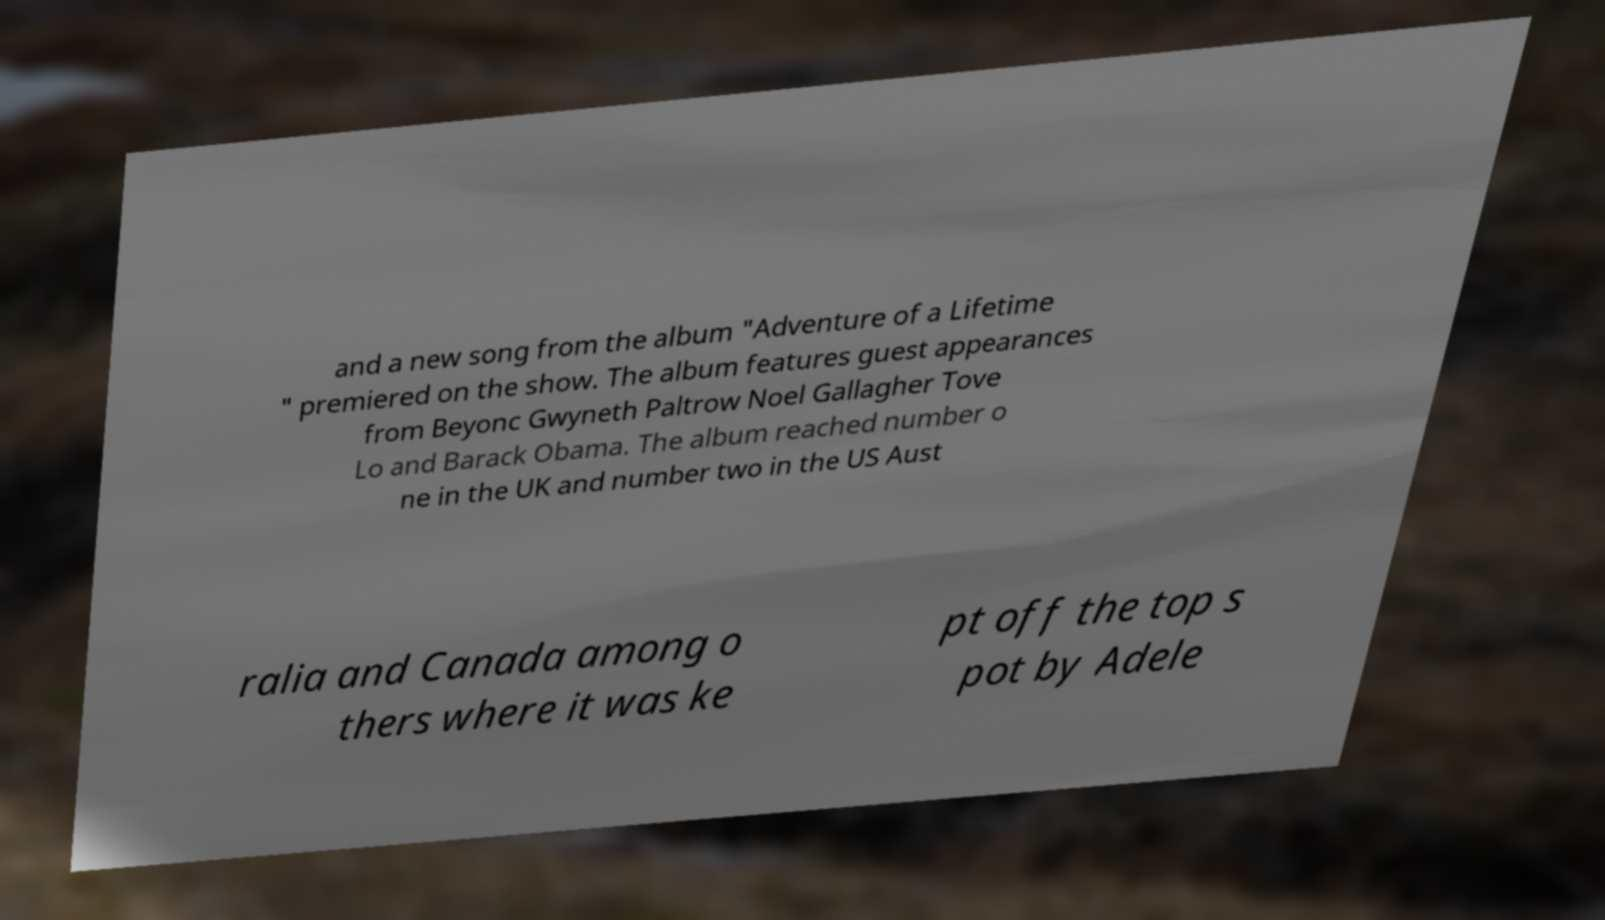There's text embedded in this image that I need extracted. Can you transcribe it verbatim? and a new song from the album "Adventure of a Lifetime " premiered on the show. The album features guest appearances from Beyonc Gwyneth Paltrow Noel Gallagher Tove Lo and Barack Obama. The album reached number o ne in the UK and number two in the US Aust ralia and Canada among o thers where it was ke pt off the top s pot by Adele 